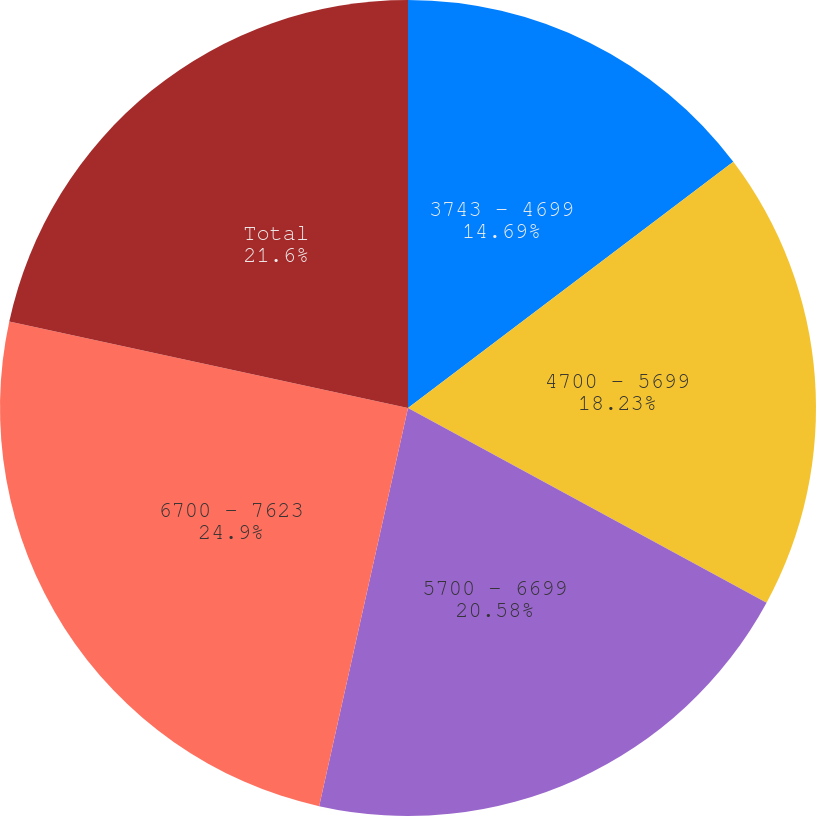Convert chart to OTSL. <chart><loc_0><loc_0><loc_500><loc_500><pie_chart><fcel>3743 - 4699<fcel>4700 - 5699<fcel>5700 - 6699<fcel>6700 - 7623<fcel>Total<nl><fcel>14.69%<fcel>18.23%<fcel>20.58%<fcel>24.91%<fcel>21.6%<nl></chart> 